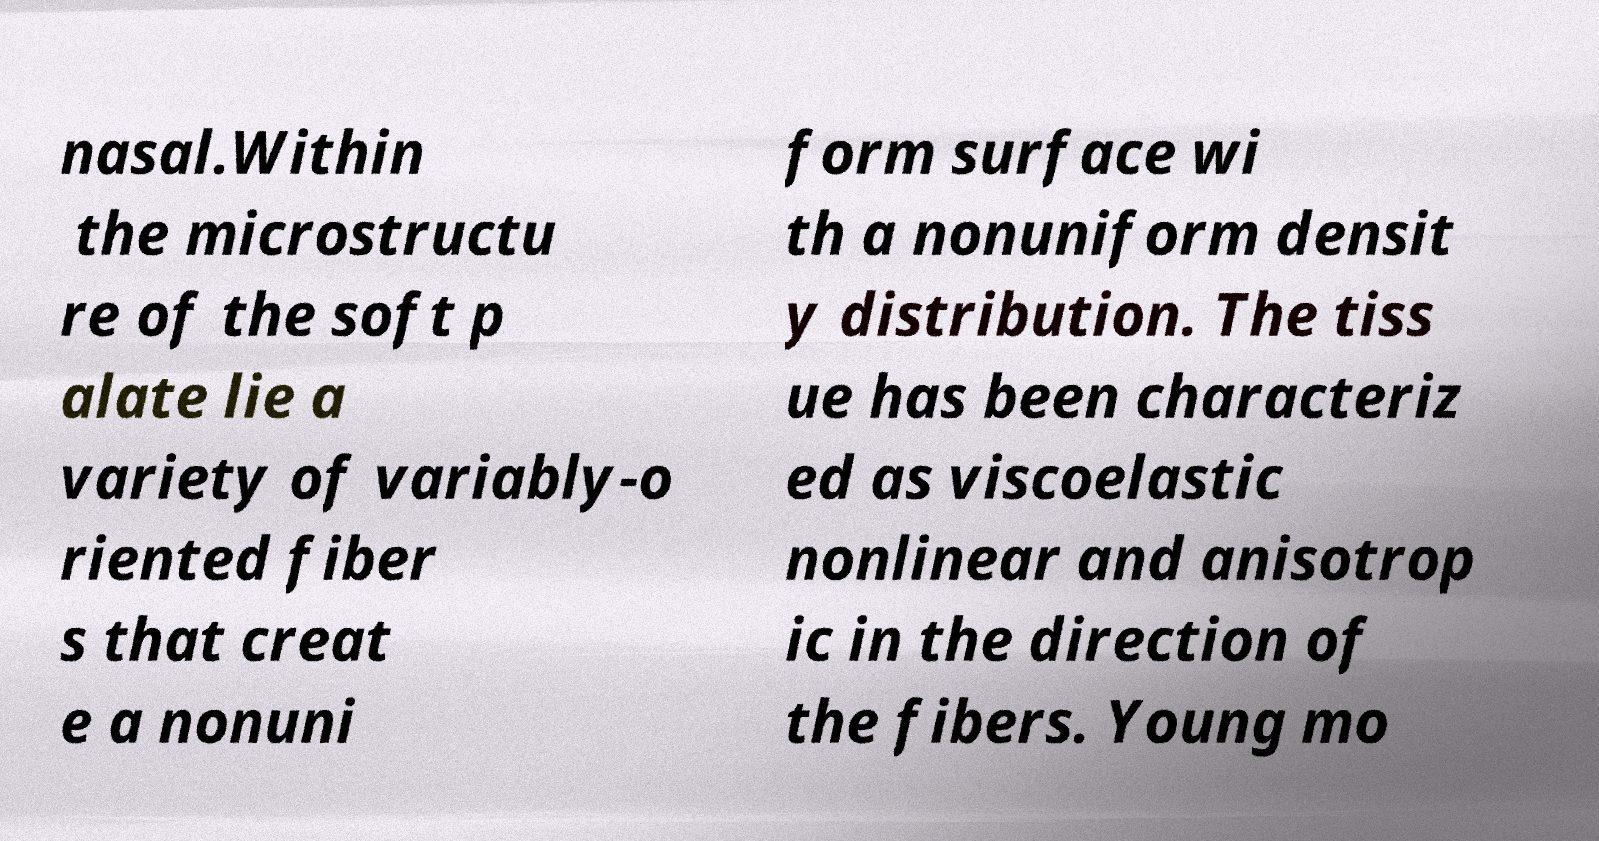Could you extract and type out the text from this image? nasal.Within the microstructu re of the soft p alate lie a variety of variably-o riented fiber s that creat e a nonuni form surface wi th a nonuniform densit y distribution. The tiss ue has been characteriz ed as viscoelastic nonlinear and anisotrop ic in the direction of the fibers. Young mo 